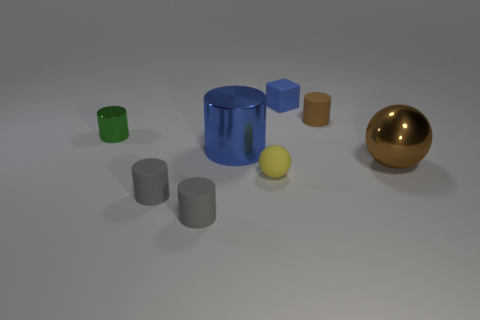Subtract all blue metal cylinders. How many cylinders are left? 4 Add 1 tiny green rubber balls. How many objects exist? 9 Subtract 4 cylinders. How many cylinders are left? 1 Subtract all tiny purple metallic spheres. Subtract all small matte things. How many objects are left? 3 Add 2 big blue things. How many big blue things are left? 3 Add 6 brown shiny cylinders. How many brown shiny cylinders exist? 6 Subtract all brown balls. How many balls are left? 1 Subtract 1 blue blocks. How many objects are left? 7 Subtract all blocks. How many objects are left? 7 Subtract all cyan blocks. Subtract all cyan cylinders. How many blocks are left? 1 